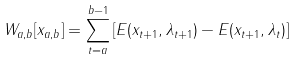Convert formula to latex. <formula><loc_0><loc_0><loc_500><loc_500>W _ { a , b } [ x _ { a , b } ] = \sum _ { t = a } ^ { b - 1 } \left [ E ( x _ { t + 1 } , \lambda _ { t + 1 } ) - E ( x _ { t + 1 } , \lambda _ { t } ) \right ]</formula> 